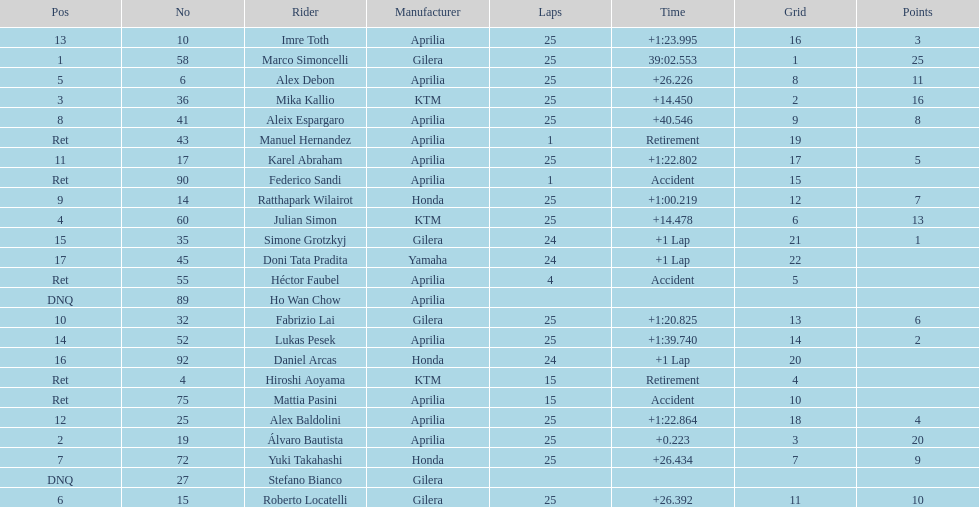Who perfomed the most number of laps, marco simoncelli or hiroshi aoyama? Marco Simoncelli. 